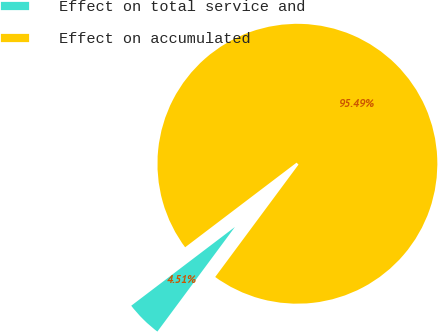<chart> <loc_0><loc_0><loc_500><loc_500><pie_chart><fcel>Effect on total service and<fcel>Effect on accumulated<nl><fcel>4.51%<fcel>95.49%<nl></chart> 